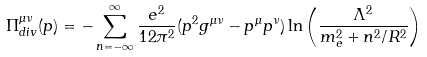Convert formula to latex. <formula><loc_0><loc_0><loc_500><loc_500>\Pi ^ { \mu \nu } _ { d i v } ( p ) = - \sum _ { n = - \infty } ^ { \infty } \frac { e ^ { 2 } } { 1 2 \pi ^ { 2 } } ( p ^ { 2 } g ^ { \mu \nu } - p ^ { \mu } p ^ { \nu } ) \ln \left ( \frac { \Lambda ^ { 2 } } { m _ { e } ^ { 2 } + n ^ { 2 } / R ^ { 2 } } \right )</formula> 